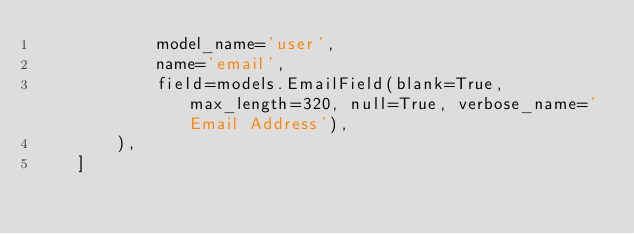Convert code to text. <code><loc_0><loc_0><loc_500><loc_500><_Python_>            model_name='user',
            name='email',
            field=models.EmailField(blank=True, max_length=320, null=True, verbose_name='Email Address'),
        ),
    ]
</code> 